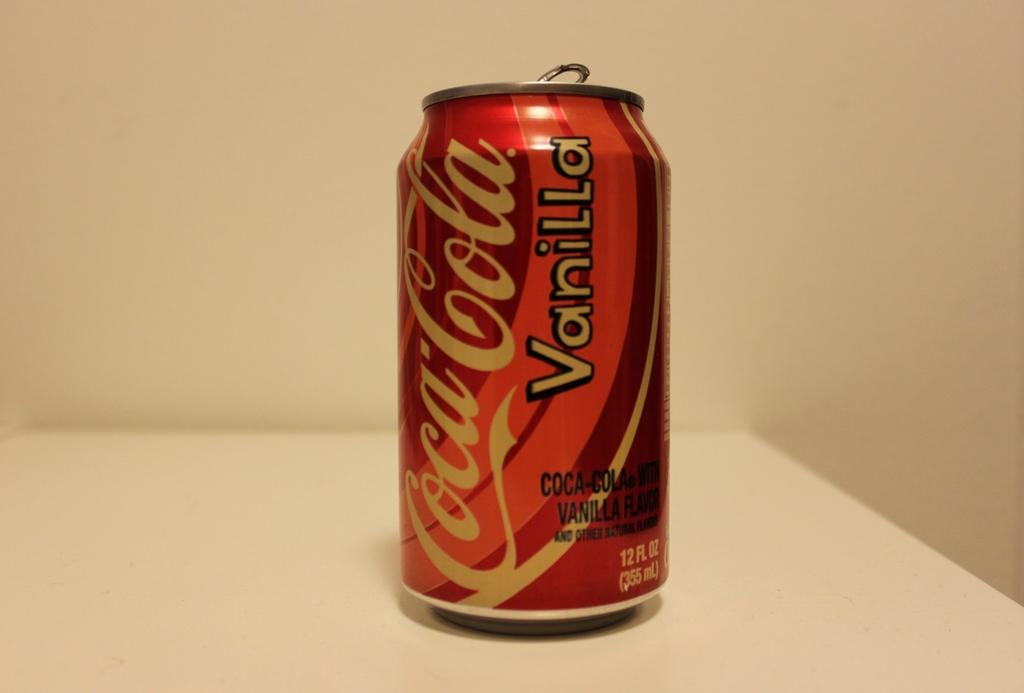<image>
Give a short and clear explanation of the subsequent image. A 12 oz can of vanilla coca cola 